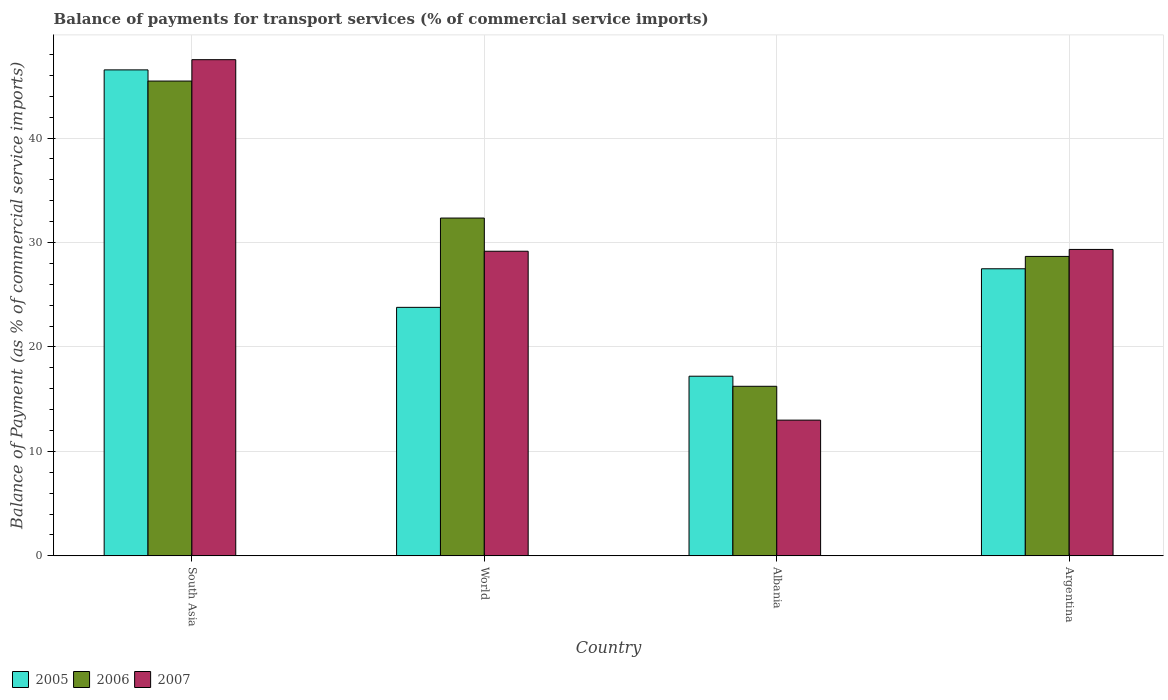Are the number of bars per tick equal to the number of legend labels?
Keep it short and to the point. Yes. What is the label of the 3rd group of bars from the left?
Provide a succinct answer. Albania. What is the balance of payments for transport services in 2005 in Argentina?
Your answer should be compact. 27.48. Across all countries, what is the maximum balance of payments for transport services in 2005?
Ensure brevity in your answer.  46.53. Across all countries, what is the minimum balance of payments for transport services in 2005?
Give a very brief answer. 17.2. In which country was the balance of payments for transport services in 2006 maximum?
Provide a short and direct response. South Asia. In which country was the balance of payments for transport services in 2007 minimum?
Provide a succinct answer. Albania. What is the total balance of payments for transport services in 2005 in the graph?
Provide a succinct answer. 115. What is the difference between the balance of payments for transport services in 2005 in Albania and that in World?
Keep it short and to the point. -6.59. What is the difference between the balance of payments for transport services in 2007 in Argentina and the balance of payments for transport services in 2005 in South Asia?
Your response must be concise. -17.19. What is the average balance of payments for transport services in 2007 per country?
Your answer should be very brief. 29.75. What is the difference between the balance of payments for transport services of/in 2006 and balance of payments for transport services of/in 2007 in World?
Offer a very short reply. 3.18. What is the ratio of the balance of payments for transport services in 2005 in Albania to that in Argentina?
Your answer should be very brief. 0.63. Is the difference between the balance of payments for transport services in 2006 in Albania and South Asia greater than the difference between the balance of payments for transport services in 2007 in Albania and South Asia?
Provide a short and direct response. Yes. What is the difference between the highest and the second highest balance of payments for transport services in 2007?
Make the answer very short. -0.17. What is the difference between the highest and the lowest balance of payments for transport services in 2005?
Your answer should be compact. 29.33. In how many countries, is the balance of payments for transport services in 2007 greater than the average balance of payments for transport services in 2007 taken over all countries?
Offer a terse response. 1. What does the 1st bar from the left in World represents?
Make the answer very short. 2005. How many bars are there?
Your answer should be very brief. 12. Are all the bars in the graph horizontal?
Make the answer very short. No. Are the values on the major ticks of Y-axis written in scientific E-notation?
Give a very brief answer. No. What is the title of the graph?
Make the answer very short. Balance of payments for transport services (% of commercial service imports). Does "2004" appear as one of the legend labels in the graph?
Your answer should be very brief. No. What is the label or title of the Y-axis?
Your answer should be compact. Balance of Payment (as % of commercial service imports). What is the Balance of Payment (as % of commercial service imports) of 2005 in South Asia?
Ensure brevity in your answer.  46.53. What is the Balance of Payment (as % of commercial service imports) in 2006 in South Asia?
Your response must be concise. 45.46. What is the Balance of Payment (as % of commercial service imports) of 2007 in South Asia?
Offer a terse response. 47.5. What is the Balance of Payment (as % of commercial service imports) of 2005 in World?
Give a very brief answer. 23.79. What is the Balance of Payment (as % of commercial service imports) of 2006 in World?
Ensure brevity in your answer.  32.34. What is the Balance of Payment (as % of commercial service imports) of 2007 in World?
Offer a very short reply. 29.16. What is the Balance of Payment (as % of commercial service imports) of 2005 in Albania?
Offer a very short reply. 17.2. What is the Balance of Payment (as % of commercial service imports) of 2006 in Albania?
Ensure brevity in your answer.  16.23. What is the Balance of Payment (as % of commercial service imports) in 2007 in Albania?
Provide a succinct answer. 12.99. What is the Balance of Payment (as % of commercial service imports) in 2005 in Argentina?
Provide a short and direct response. 27.48. What is the Balance of Payment (as % of commercial service imports) in 2006 in Argentina?
Offer a terse response. 28.67. What is the Balance of Payment (as % of commercial service imports) in 2007 in Argentina?
Keep it short and to the point. 29.34. Across all countries, what is the maximum Balance of Payment (as % of commercial service imports) of 2005?
Make the answer very short. 46.53. Across all countries, what is the maximum Balance of Payment (as % of commercial service imports) in 2006?
Offer a very short reply. 45.46. Across all countries, what is the maximum Balance of Payment (as % of commercial service imports) in 2007?
Your response must be concise. 47.5. Across all countries, what is the minimum Balance of Payment (as % of commercial service imports) in 2005?
Offer a very short reply. 17.2. Across all countries, what is the minimum Balance of Payment (as % of commercial service imports) of 2006?
Your answer should be very brief. 16.23. Across all countries, what is the minimum Balance of Payment (as % of commercial service imports) in 2007?
Your answer should be very brief. 12.99. What is the total Balance of Payment (as % of commercial service imports) of 2005 in the graph?
Offer a very short reply. 115. What is the total Balance of Payment (as % of commercial service imports) in 2006 in the graph?
Make the answer very short. 122.69. What is the total Balance of Payment (as % of commercial service imports) of 2007 in the graph?
Provide a short and direct response. 118.99. What is the difference between the Balance of Payment (as % of commercial service imports) of 2005 in South Asia and that in World?
Make the answer very short. 22.74. What is the difference between the Balance of Payment (as % of commercial service imports) of 2006 in South Asia and that in World?
Make the answer very short. 13.12. What is the difference between the Balance of Payment (as % of commercial service imports) of 2007 in South Asia and that in World?
Keep it short and to the point. 18.34. What is the difference between the Balance of Payment (as % of commercial service imports) of 2005 in South Asia and that in Albania?
Ensure brevity in your answer.  29.33. What is the difference between the Balance of Payment (as % of commercial service imports) of 2006 in South Asia and that in Albania?
Offer a very short reply. 29.22. What is the difference between the Balance of Payment (as % of commercial service imports) of 2007 in South Asia and that in Albania?
Ensure brevity in your answer.  34.51. What is the difference between the Balance of Payment (as % of commercial service imports) in 2005 in South Asia and that in Argentina?
Give a very brief answer. 19.04. What is the difference between the Balance of Payment (as % of commercial service imports) of 2006 in South Asia and that in Argentina?
Ensure brevity in your answer.  16.79. What is the difference between the Balance of Payment (as % of commercial service imports) of 2007 in South Asia and that in Argentina?
Your answer should be compact. 18.17. What is the difference between the Balance of Payment (as % of commercial service imports) in 2005 in World and that in Albania?
Provide a short and direct response. 6.59. What is the difference between the Balance of Payment (as % of commercial service imports) in 2006 in World and that in Albania?
Ensure brevity in your answer.  16.11. What is the difference between the Balance of Payment (as % of commercial service imports) in 2007 in World and that in Albania?
Your answer should be compact. 16.17. What is the difference between the Balance of Payment (as % of commercial service imports) in 2005 in World and that in Argentina?
Ensure brevity in your answer.  -3.69. What is the difference between the Balance of Payment (as % of commercial service imports) of 2006 in World and that in Argentina?
Keep it short and to the point. 3.67. What is the difference between the Balance of Payment (as % of commercial service imports) in 2007 in World and that in Argentina?
Offer a terse response. -0.17. What is the difference between the Balance of Payment (as % of commercial service imports) in 2005 in Albania and that in Argentina?
Provide a succinct answer. -10.29. What is the difference between the Balance of Payment (as % of commercial service imports) of 2006 in Albania and that in Argentina?
Your answer should be compact. -12.43. What is the difference between the Balance of Payment (as % of commercial service imports) of 2007 in Albania and that in Argentina?
Keep it short and to the point. -16.34. What is the difference between the Balance of Payment (as % of commercial service imports) of 2005 in South Asia and the Balance of Payment (as % of commercial service imports) of 2006 in World?
Provide a short and direct response. 14.19. What is the difference between the Balance of Payment (as % of commercial service imports) in 2005 in South Asia and the Balance of Payment (as % of commercial service imports) in 2007 in World?
Provide a succinct answer. 17.36. What is the difference between the Balance of Payment (as % of commercial service imports) in 2006 in South Asia and the Balance of Payment (as % of commercial service imports) in 2007 in World?
Offer a terse response. 16.29. What is the difference between the Balance of Payment (as % of commercial service imports) in 2005 in South Asia and the Balance of Payment (as % of commercial service imports) in 2006 in Albania?
Your response must be concise. 30.29. What is the difference between the Balance of Payment (as % of commercial service imports) in 2005 in South Asia and the Balance of Payment (as % of commercial service imports) in 2007 in Albania?
Ensure brevity in your answer.  33.53. What is the difference between the Balance of Payment (as % of commercial service imports) in 2006 in South Asia and the Balance of Payment (as % of commercial service imports) in 2007 in Albania?
Keep it short and to the point. 32.46. What is the difference between the Balance of Payment (as % of commercial service imports) in 2005 in South Asia and the Balance of Payment (as % of commercial service imports) in 2006 in Argentina?
Provide a succinct answer. 17.86. What is the difference between the Balance of Payment (as % of commercial service imports) in 2005 in South Asia and the Balance of Payment (as % of commercial service imports) in 2007 in Argentina?
Provide a short and direct response. 17.19. What is the difference between the Balance of Payment (as % of commercial service imports) of 2006 in South Asia and the Balance of Payment (as % of commercial service imports) of 2007 in Argentina?
Offer a very short reply. 16.12. What is the difference between the Balance of Payment (as % of commercial service imports) in 2005 in World and the Balance of Payment (as % of commercial service imports) in 2006 in Albania?
Keep it short and to the point. 7.56. What is the difference between the Balance of Payment (as % of commercial service imports) in 2005 in World and the Balance of Payment (as % of commercial service imports) in 2007 in Albania?
Make the answer very short. 10.8. What is the difference between the Balance of Payment (as % of commercial service imports) of 2006 in World and the Balance of Payment (as % of commercial service imports) of 2007 in Albania?
Your response must be concise. 19.35. What is the difference between the Balance of Payment (as % of commercial service imports) in 2005 in World and the Balance of Payment (as % of commercial service imports) in 2006 in Argentina?
Make the answer very short. -4.88. What is the difference between the Balance of Payment (as % of commercial service imports) of 2005 in World and the Balance of Payment (as % of commercial service imports) of 2007 in Argentina?
Make the answer very short. -5.55. What is the difference between the Balance of Payment (as % of commercial service imports) of 2006 in World and the Balance of Payment (as % of commercial service imports) of 2007 in Argentina?
Your response must be concise. 3. What is the difference between the Balance of Payment (as % of commercial service imports) in 2005 in Albania and the Balance of Payment (as % of commercial service imports) in 2006 in Argentina?
Your answer should be compact. -11.47. What is the difference between the Balance of Payment (as % of commercial service imports) in 2005 in Albania and the Balance of Payment (as % of commercial service imports) in 2007 in Argentina?
Make the answer very short. -12.14. What is the difference between the Balance of Payment (as % of commercial service imports) of 2006 in Albania and the Balance of Payment (as % of commercial service imports) of 2007 in Argentina?
Provide a succinct answer. -13.1. What is the average Balance of Payment (as % of commercial service imports) of 2005 per country?
Your answer should be compact. 28.75. What is the average Balance of Payment (as % of commercial service imports) in 2006 per country?
Give a very brief answer. 30.67. What is the average Balance of Payment (as % of commercial service imports) of 2007 per country?
Offer a very short reply. 29.75. What is the difference between the Balance of Payment (as % of commercial service imports) in 2005 and Balance of Payment (as % of commercial service imports) in 2006 in South Asia?
Your answer should be compact. 1.07. What is the difference between the Balance of Payment (as % of commercial service imports) in 2005 and Balance of Payment (as % of commercial service imports) in 2007 in South Asia?
Offer a very short reply. -0.98. What is the difference between the Balance of Payment (as % of commercial service imports) in 2006 and Balance of Payment (as % of commercial service imports) in 2007 in South Asia?
Make the answer very short. -2.05. What is the difference between the Balance of Payment (as % of commercial service imports) in 2005 and Balance of Payment (as % of commercial service imports) in 2006 in World?
Offer a terse response. -8.55. What is the difference between the Balance of Payment (as % of commercial service imports) of 2005 and Balance of Payment (as % of commercial service imports) of 2007 in World?
Ensure brevity in your answer.  -5.37. What is the difference between the Balance of Payment (as % of commercial service imports) of 2006 and Balance of Payment (as % of commercial service imports) of 2007 in World?
Make the answer very short. 3.18. What is the difference between the Balance of Payment (as % of commercial service imports) of 2005 and Balance of Payment (as % of commercial service imports) of 2006 in Albania?
Ensure brevity in your answer.  0.97. What is the difference between the Balance of Payment (as % of commercial service imports) in 2005 and Balance of Payment (as % of commercial service imports) in 2007 in Albania?
Offer a terse response. 4.2. What is the difference between the Balance of Payment (as % of commercial service imports) of 2006 and Balance of Payment (as % of commercial service imports) of 2007 in Albania?
Your answer should be compact. 3.24. What is the difference between the Balance of Payment (as % of commercial service imports) of 2005 and Balance of Payment (as % of commercial service imports) of 2006 in Argentina?
Make the answer very short. -1.18. What is the difference between the Balance of Payment (as % of commercial service imports) of 2005 and Balance of Payment (as % of commercial service imports) of 2007 in Argentina?
Give a very brief answer. -1.85. What is the difference between the Balance of Payment (as % of commercial service imports) of 2006 and Balance of Payment (as % of commercial service imports) of 2007 in Argentina?
Ensure brevity in your answer.  -0.67. What is the ratio of the Balance of Payment (as % of commercial service imports) of 2005 in South Asia to that in World?
Provide a succinct answer. 1.96. What is the ratio of the Balance of Payment (as % of commercial service imports) in 2006 in South Asia to that in World?
Your answer should be very brief. 1.41. What is the ratio of the Balance of Payment (as % of commercial service imports) of 2007 in South Asia to that in World?
Provide a succinct answer. 1.63. What is the ratio of the Balance of Payment (as % of commercial service imports) of 2005 in South Asia to that in Albania?
Ensure brevity in your answer.  2.71. What is the ratio of the Balance of Payment (as % of commercial service imports) in 2006 in South Asia to that in Albania?
Your answer should be compact. 2.8. What is the ratio of the Balance of Payment (as % of commercial service imports) in 2007 in South Asia to that in Albania?
Provide a succinct answer. 3.66. What is the ratio of the Balance of Payment (as % of commercial service imports) in 2005 in South Asia to that in Argentina?
Keep it short and to the point. 1.69. What is the ratio of the Balance of Payment (as % of commercial service imports) in 2006 in South Asia to that in Argentina?
Provide a short and direct response. 1.59. What is the ratio of the Balance of Payment (as % of commercial service imports) of 2007 in South Asia to that in Argentina?
Your response must be concise. 1.62. What is the ratio of the Balance of Payment (as % of commercial service imports) in 2005 in World to that in Albania?
Make the answer very short. 1.38. What is the ratio of the Balance of Payment (as % of commercial service imports) in 2006 in World to that in Albania?
Your answer should be compact. 1.99. What is the ratio of the Balance of Payment (as % of commercial service imports) of 2007 in World to that in Albania?
Keep it short and to the point. 2.24. What is the ratio of the Balance of Payment (as % of commercial service imports) of 2005 in World to that in Argentina?
Your answer should be compact. 0.87. What is the ratio of the Balance of Payment (as % of commercial service imports) in 2006 in World to that in Argentina?
Make the answer very short. 1.13. What is the ratio of the Balance of Payment (as % of commercial service imports) in 2007 in World to that in Argentina?
Offer a terse response. 0.99. What is the ratio of the Balance of Payment (as % of commercial service imports) of 2005 in Albania to that in Argentina?
Ensure brevity in your answer.  0.63. What is the ratio of the Balance of Payment (as % of commercial service imports) in 2006 in Albania to that in Argentina?
Give a very brief answer. 0.57. What is the ratio of the Balance of Payment (as % of commercial service imports) of 2007 in Albania to that in Argentina?
Your answer should be compact. 0.44. What is the difference between the highest and the second highest Balance of Payment (as % of commercial service imports) in 2005?
Your response must be concise. 19.04. What is the difference between the highest and the second highest Balance of Payment (as % of commercial service imports) of 2006?
Your answer should be very brief. 13.12. What is the difference between the highest and the second highest Balance of Payment (as % of commercial service imports) in 2007?
Offer a terse response. 18.17. What is the difference between the highest and the lowest Balance of Payment (as % of commercial service imports) of 2005?
Your answer should be very brief. 29.33. What is the difference between the highest and the lowest Balance of Payment (as % of commercial service imports) in 2006?
Your answer should be very brief. 29.22. What is the difference between the highest and the lowest Balance of Payment (as % of commercial service imports) in 2007?
Offer a terse response. 34.51. 